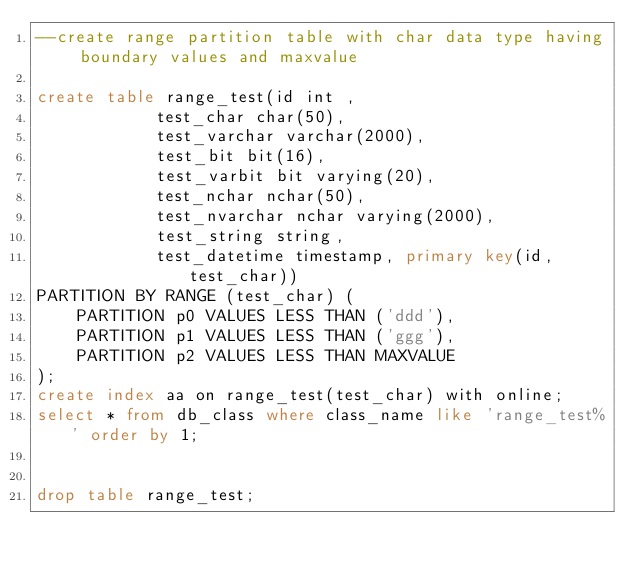Convert code to text. <code><loc_0><loc_0><loc_500><loc_500><_SQL_>--create range partition table with char data type having boundary values and maxvalue

create table range_test(id int ,
			test_char char(50),
			test_varchar varchar(2000),
			test_bit bit(16),
			test_varbit bit varying(20),
			test_nchar nchar(50),
			test_nvarchar nchar varying(2000),
			test_string string,
			test_datetime timestamp, primary key(id,test_char))
PARTITION BY RANGE (test_char) (
    PARTITION p0 VALUES LESS THAN ('ddd'),
    PARTITION p1 VALUES LESS THAN ('ggg'),
    PARTITION p2 VALUES LESS THAN MAXVALUE
);
create index aa on range_test(test_char) with online;
select * from db_class where class_name like 'range_test%' order by 1;


drop table range_test;
</code> 